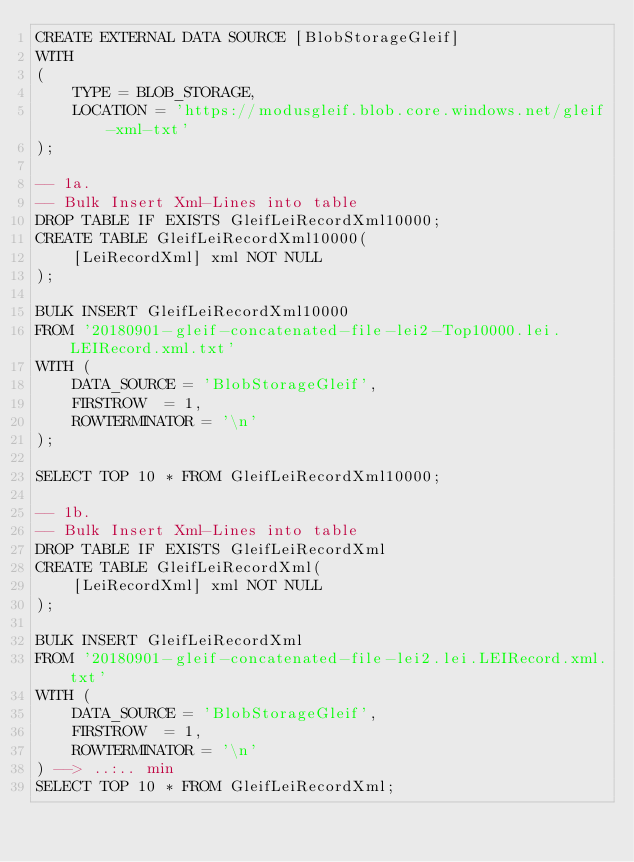Convert code to text. <code><loc_0><loc_0><loc_500><loc_500><_SQL_>CREATE EXTERNAL DATA SOURCE [BlobStorageGleif]
WITH 
( 
	TYPE = BLOB_STORAGE,
 	LOCATION = 'https://modusgleif.blob.core.windows.net/gleif-xml-txt'
);

-- 1a.
-- Bulk Insert Xml-Lines into table 
DROP TABLE IF EXISTS GleifLeiRecordXml10000;
CREATE TABLE GleifLeiRecordXml10000(
	[LeiRecordXml] xml NOT NULL
);

BULK INSERT GleifLeiRecordXml10000
FROM '20180901-gleif-concatenated-file-lei2-Top10000.lei.LEIRecord.xml.txt'
WITH (
	DATA_SOURCE = 'BlobStorageGleif',
	FIRSTROW  = 1,
	ROWTERMINATOR = '\n'
);

SELECT TOP 10 * FROM GleifLeiRecordXml10000;

-- 1b.
-- Bulk Insert Xml-Lines into table 
DROP TABLE IF EXISTS GleifLeiRecordXml
CREATE TABLE GleifLeiRecordXml(
	[LeiRecordXml] xml NOT NULL
);

BULK INSERT GleifLeiRecordXml
FROM '20180901-gleif-concatenated-file-lei2.lei.LEIRecord.xml.txt' 
WITH (
	DATA_SOURCE = 'BlobStorageGleif',
	FIRSTROW  = 1,
	ROWTERMINATOR = '\n'
) --> ..:.. min
SELECT TOP 10 * FROM GleifLeiRecordXml;
</code> 